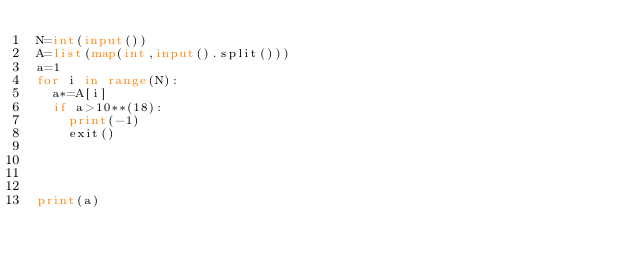Convert code to text. <code><loc_0><loc_0><loc_500><loc_500><_Python_>N=int(input())
A=list(map(int,input().split()))
a=1
for i in range(N):
  a*=A[i]
  if a>10**(18):
    print(-1)
    exit()

    
    
    
print(a)


</code> 